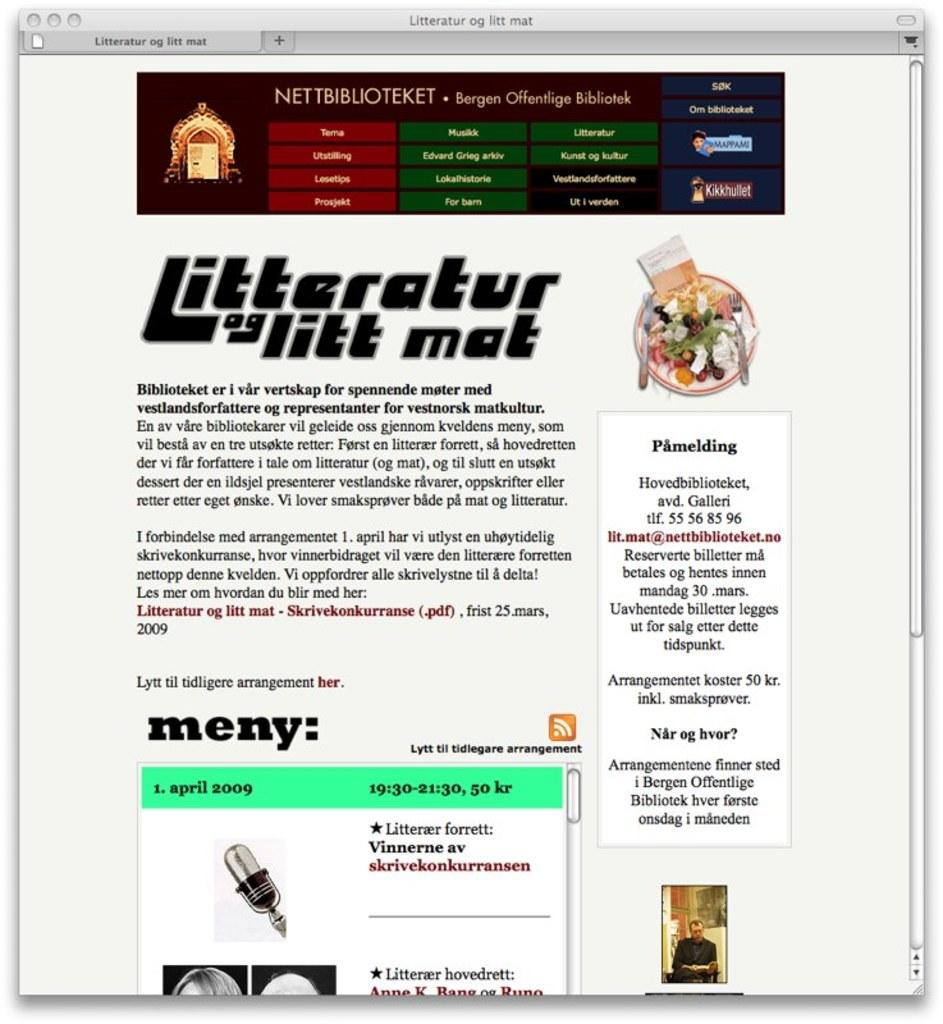What is the main feature of the image? The image contains a screen. What can be seen on the screen? There is text and an image on the screen. What type of punishment is being given to the parent in the image? There is no parent or punishment present in the image; it only contains a screen with text and an image. 